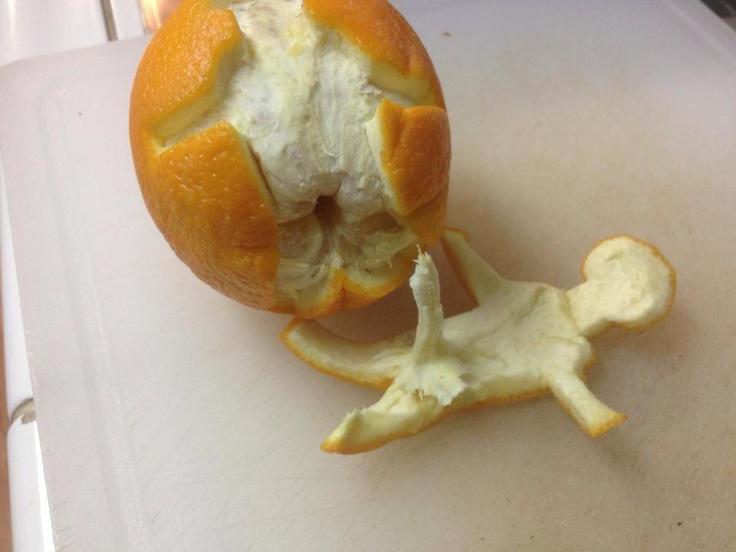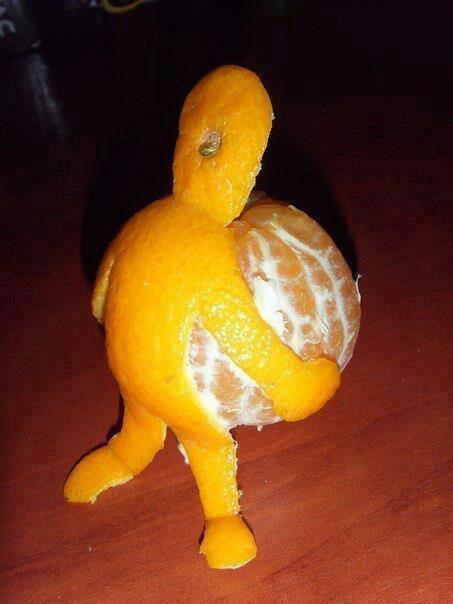The first image is the image on the left, the second image is the image on the right. Evaluate the accuracy of this statement regarding the images: "In one of the images, the orange peel looks like a man that is carrying the orange as it walks.". Is it true? Answer yes or no. Yes. The first image is the image on the left, the second image is the image on the right. For the images shown, is this caption "there is an orange peeled in a way that it looks like a person carrying a ball" true? Answer yes or no. Yes. 